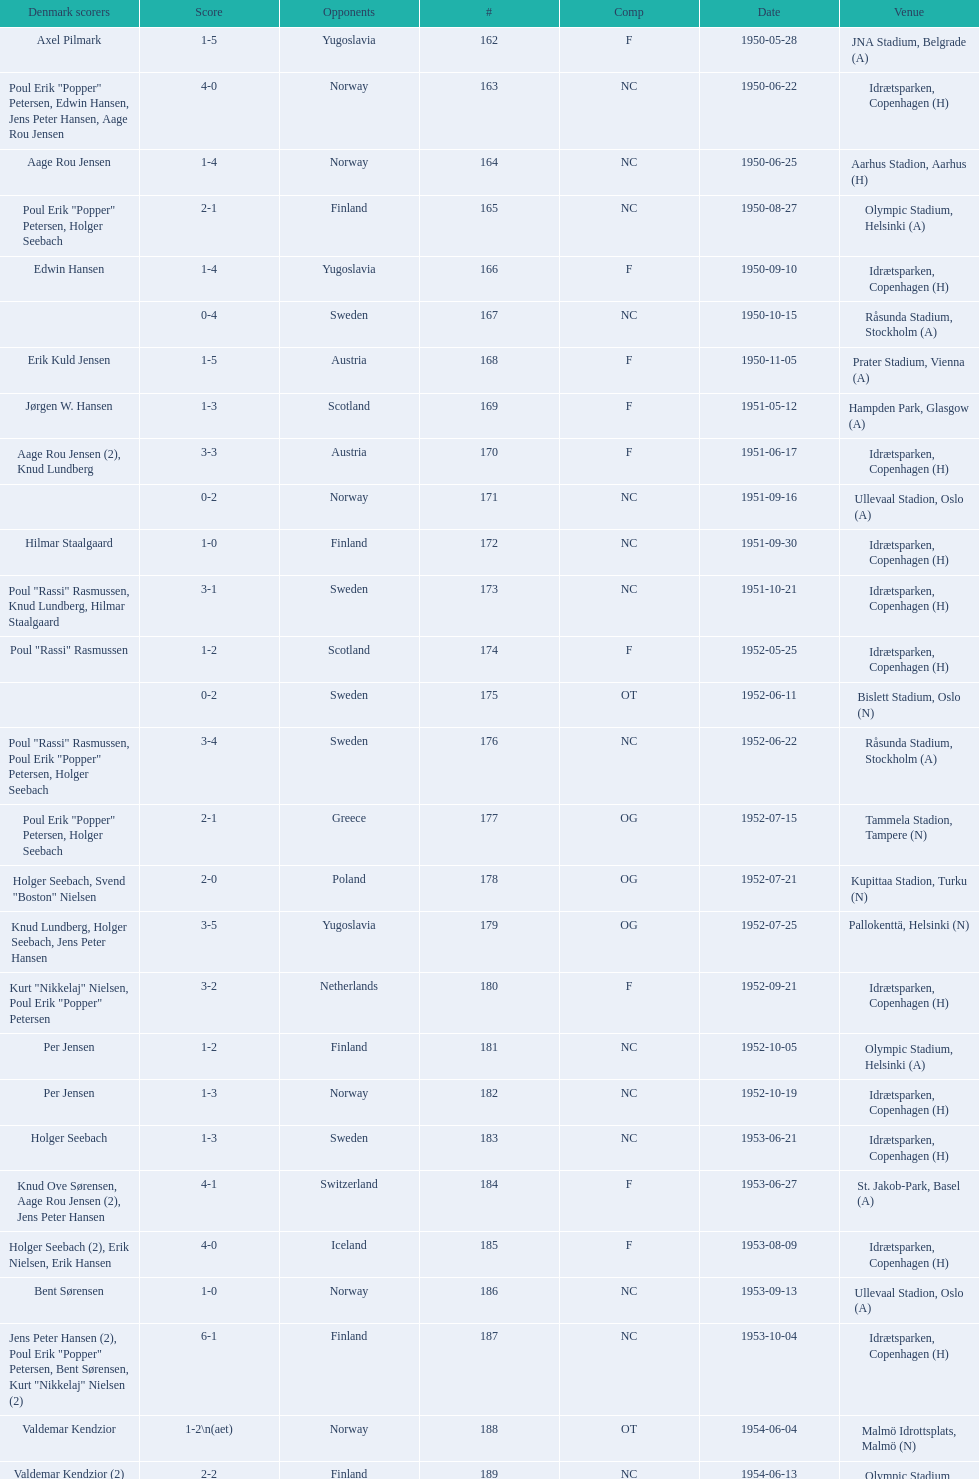How many times does nc show up in the comp column? 32. 